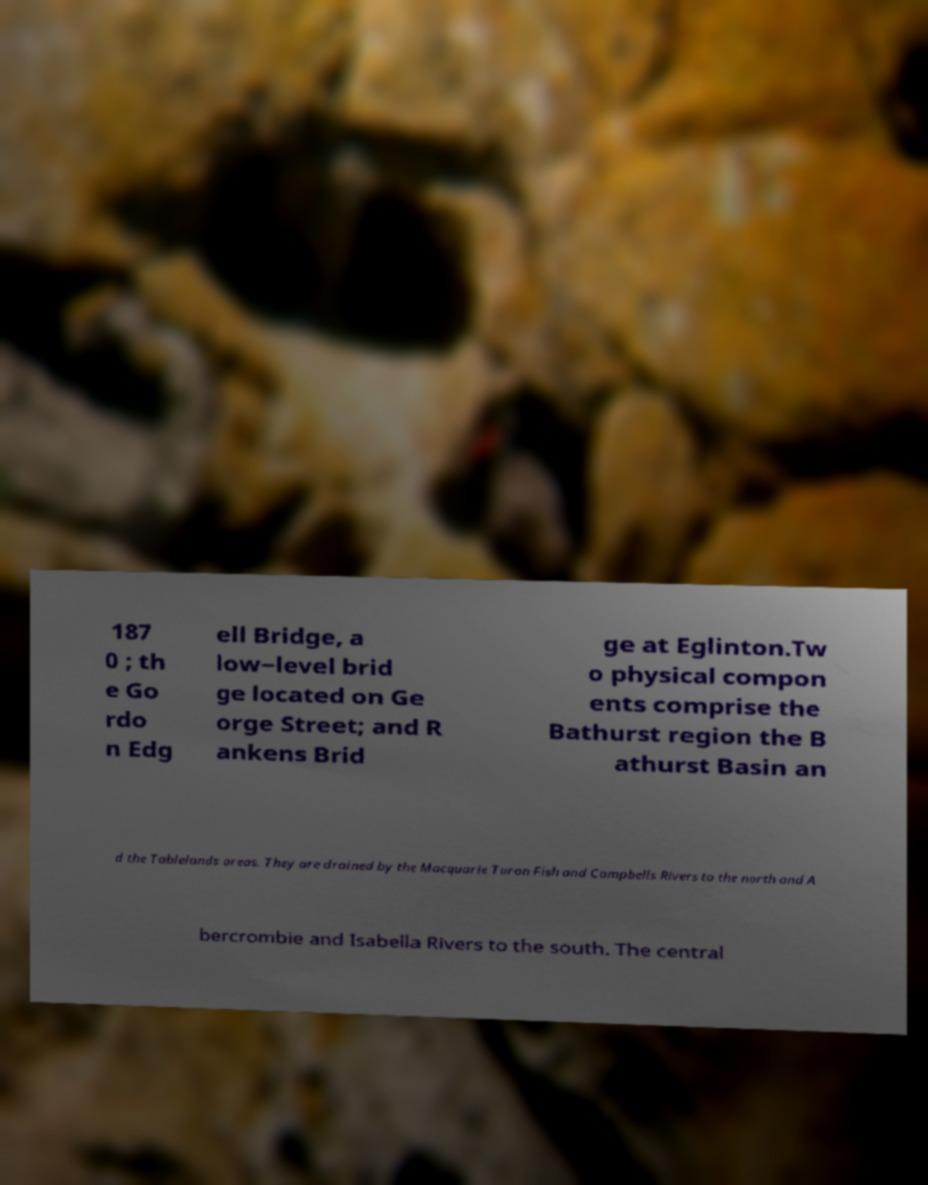Can you accurately transcribe the text from the provided image for me? 187 0 ; th e Go rdo n Edg ell Bridge, a low−level brid ge located on Ge orge Street; and R ankens Brid ge at Eglinton.Tw o physical compon ents comprise the Bathurst region the B athurst Basin an d the Tablelands areas. They are drained by the Macquarie Turon Fish and Campbells Rivers to the north and A bercrombie and Isabella Rivers to the south. The central 